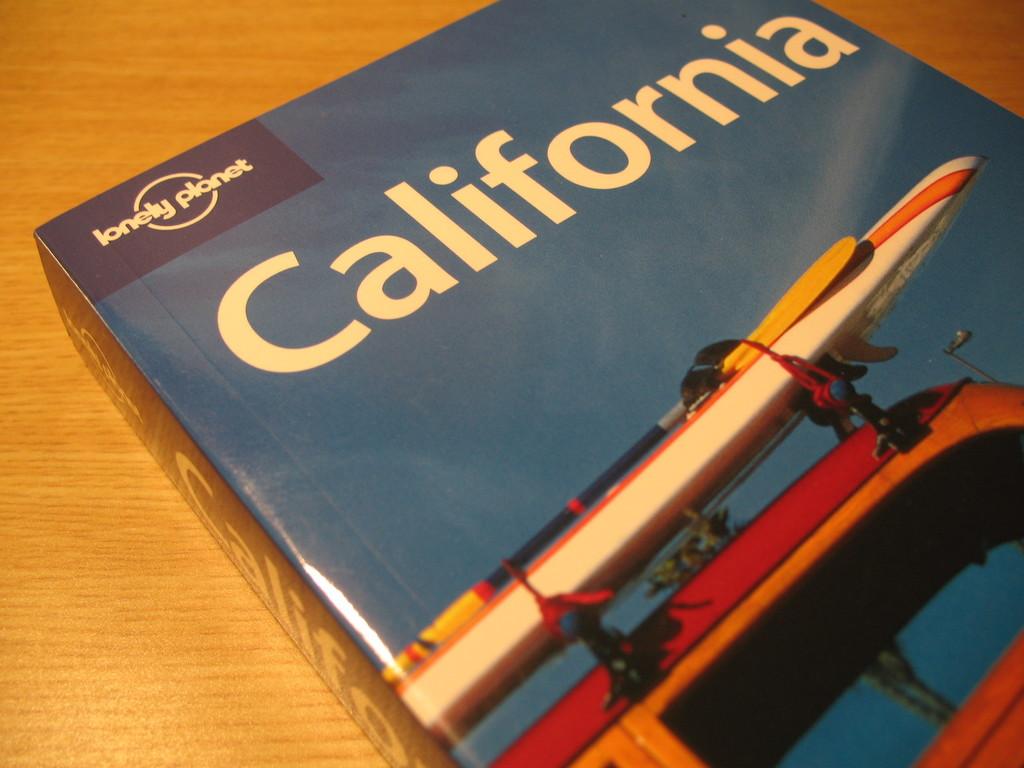What is the book about?
Provide a short and direct response. California. What is the series name in the top left corner?
Provide a succinct answer. Lonely planet. 